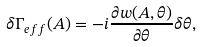Convert formula to latex. <formula><loc_0><loc_0><loc_500><loc_500>\delta \Gamma _ { e f f } ( A ) = - i \frac { \partial w ( A , \theta ) } { \partial \theta } \delta \theta ,</formula> 